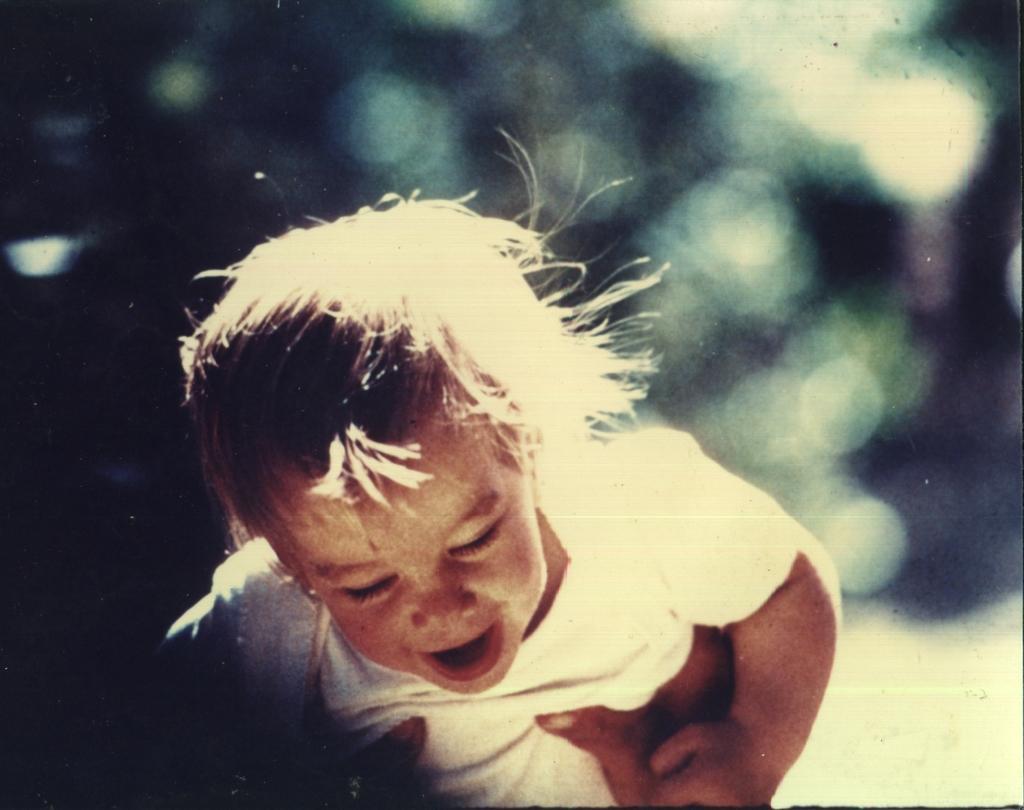In one or two sentences, can you explain what this image depicts? In this picture we can see a person hands holding a child and in the background it is blurry. 